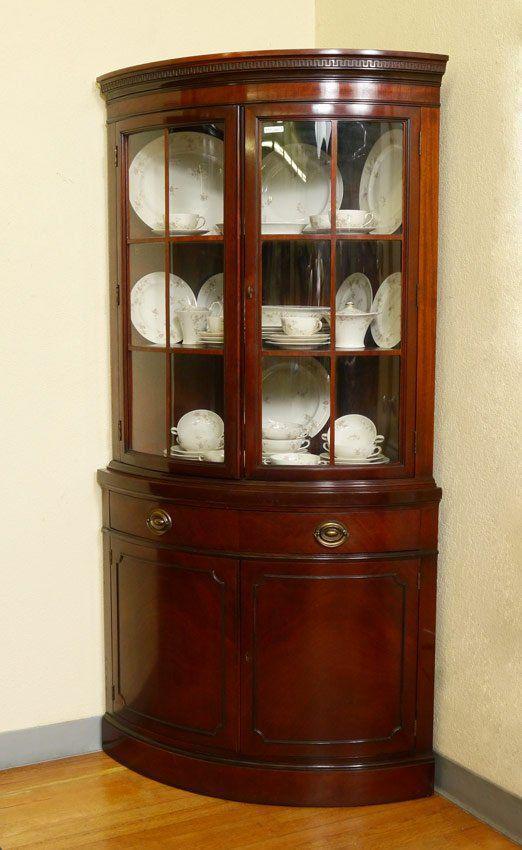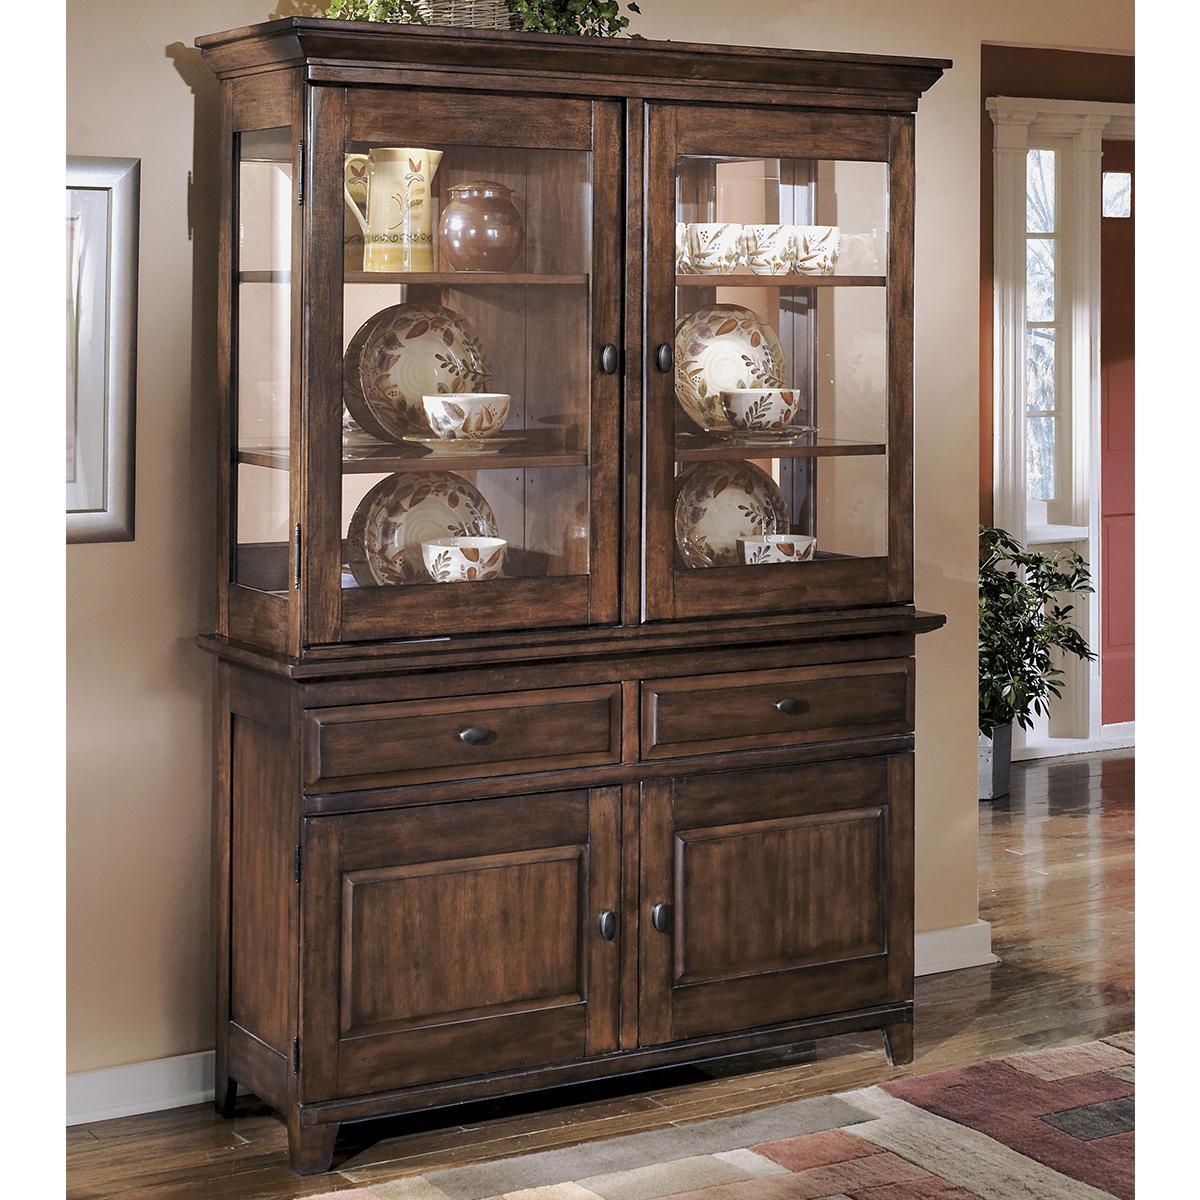The first image is the image on the left, the second image is the image on the right. For the images shown, is this caption "a picture frame is visible on the right image." true? Answer yes or no. Yes. 